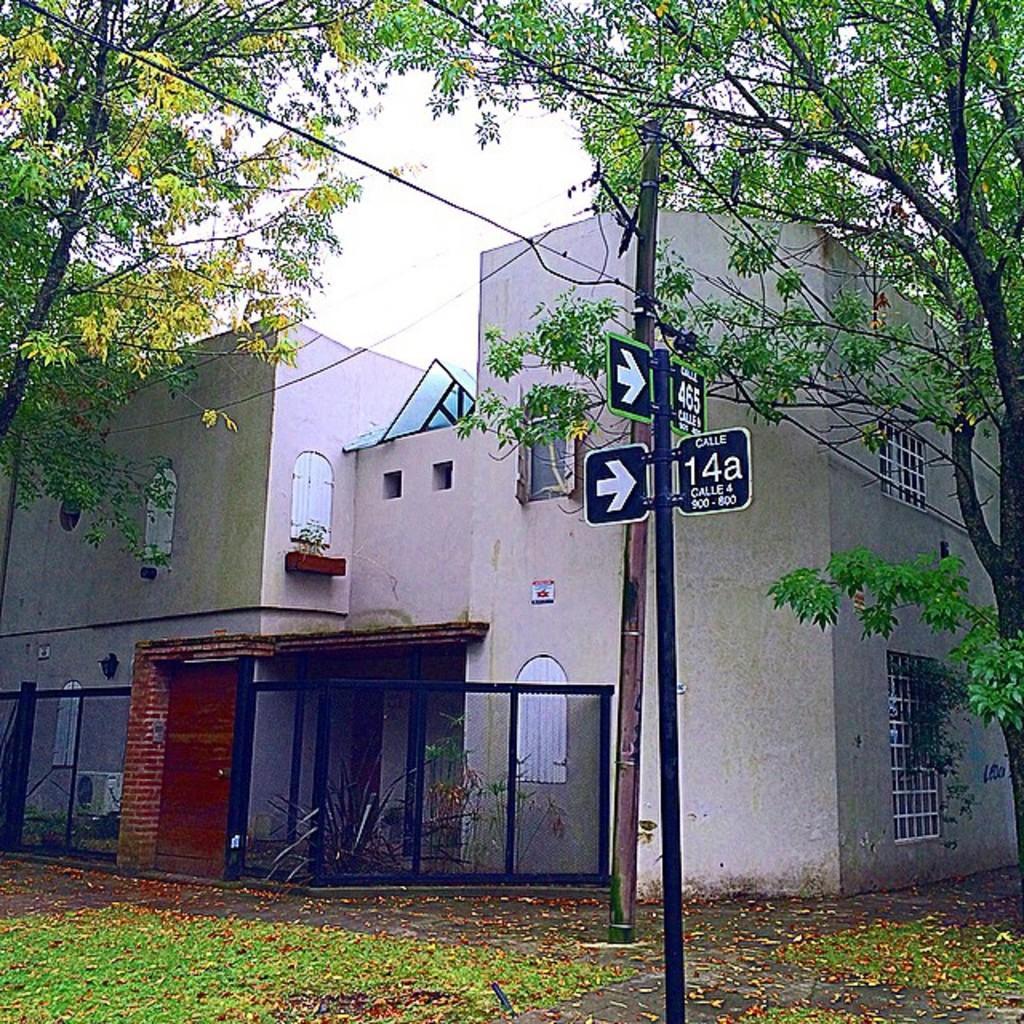How would you summarize this image in a sentence or two? In this image in the center there is one house, gate, wall, flower pots and some plants. In the foreground there are two poles, boards and some wires and on the right side and left side there are some trees. At the bottom there are some leaves and sand. 